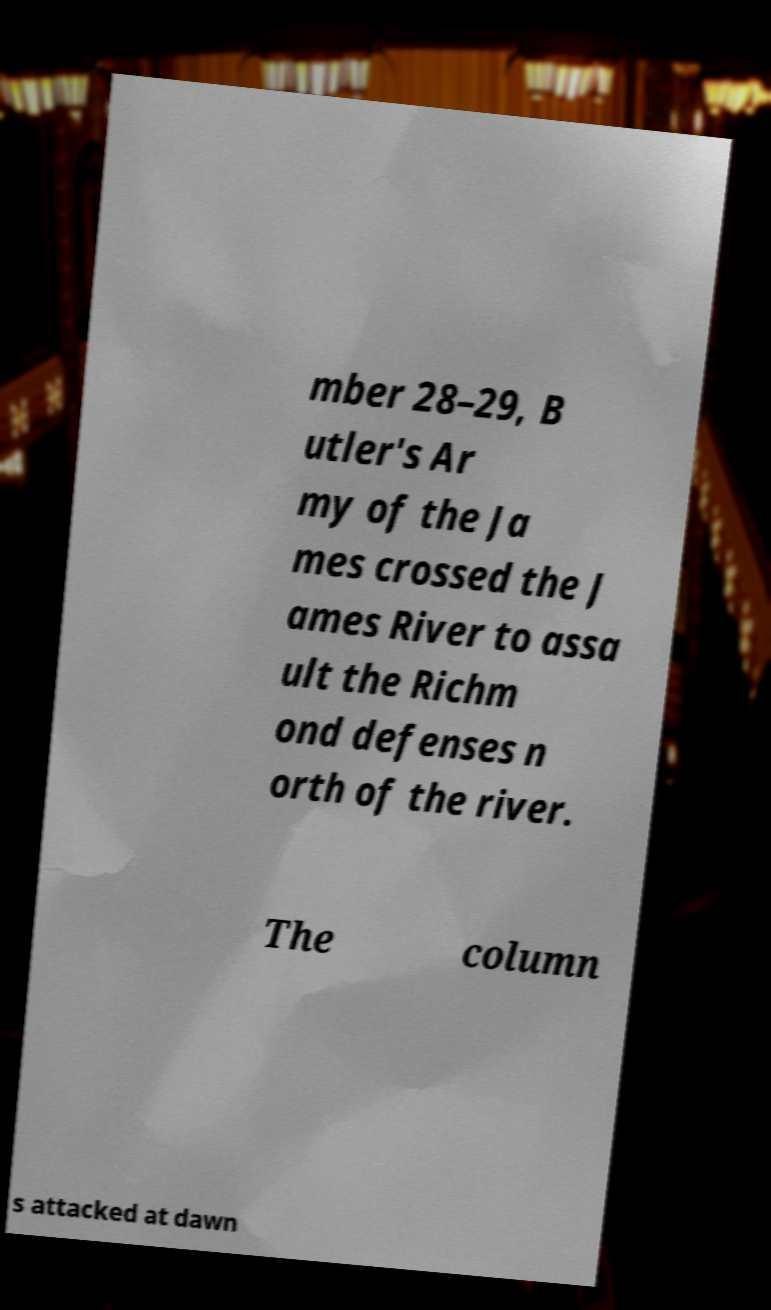Could you extract and type out the text from this image? mber 28–29, B utler's Ar my of the Ja mes crossed the J ames River to assa ult the Richm ond defenses n orth of the river. The column s attacked at dawn 